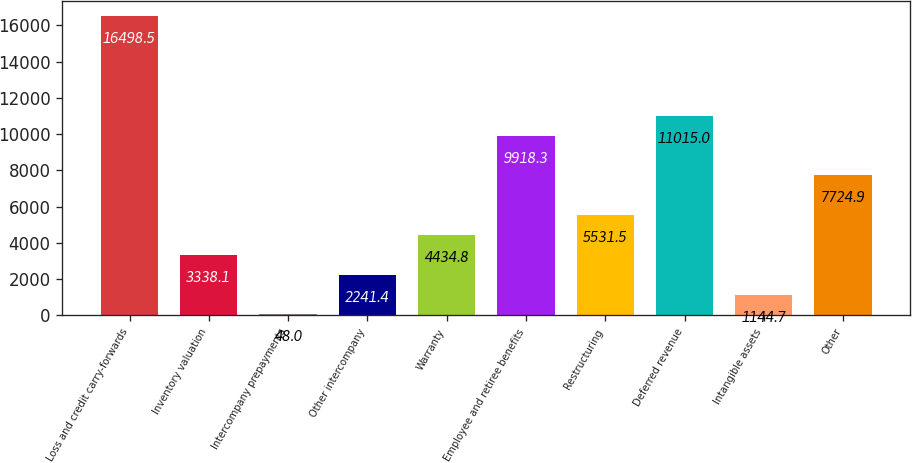Convert chart. <chart><loc_0><loc_0><loc_500><loc_500><bar_chart><fcel>Loss and credit carry-forwards<fcel>Inventory valuation<fcel>Intercompany prepayments<fcel>Other intercompany<fcel>Warranty<fcel>Employee and retiree benefits<fcel>Restructuring<fcel>Deferred revenue<fcel>Intangible assets<fcel>Other<nl><fcel>16498.5<fcel>3338.1<fcel>48<fcel>2241.4<fcel>4434.8<fcel>9918.3<fcel>5531.5<fcel>11015<fcel>1144.7<fcel>7724.9<nl></chart> 